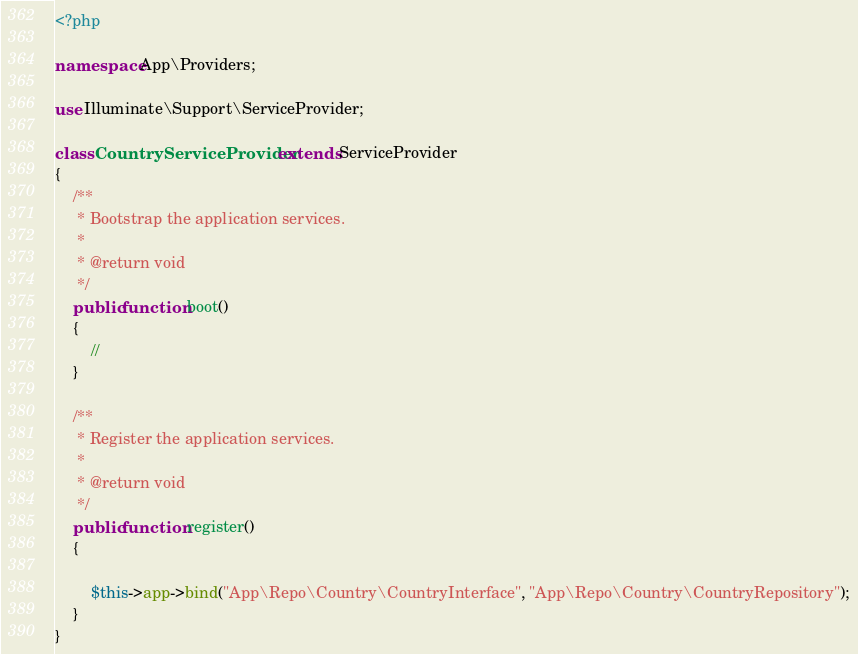Convert code to text. <code><loc_0><loc_0><loc_500><loc_500><_PHP_><?php

namespace App\Providers;

use Illuminate\Support\ServiceProvider;

class CountryServiceProvider extends ServiceProvider
{
    /**
     * Bootstrap the application services.
     *
     * @return void
     */
    public function boot()
    {
        //
    }

    /**
     * Register the application services.
     *
     * @return void
     */
    public function register()
    {
        
        $this->app->bind("App\Repo\Country\CountryInterface", "App\Repo\Country\CountryRepository");
    }
}
</code> 